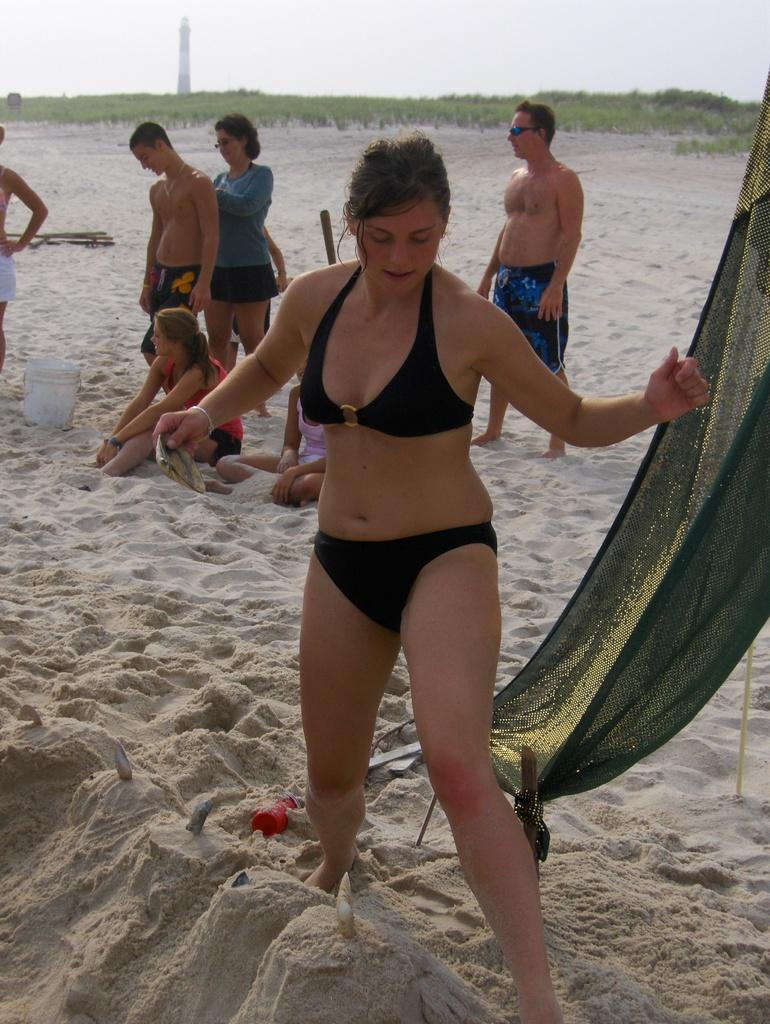What is the main subject of the image? There is a beautiful woman in the image. How is the woman positioned in the image? The woman is standing. What color are the clothes the woman is wearing? The woman is wearing black clothes. What is the man in the image standing on? The man is standing on sand in the image. Where are the people located in the image? There are people on the left side of the image. What type of bat is flying in the image? There is no bat present in the image. Is there a letter addressed to the woman in the image? There is no mention of a letter in the image. 